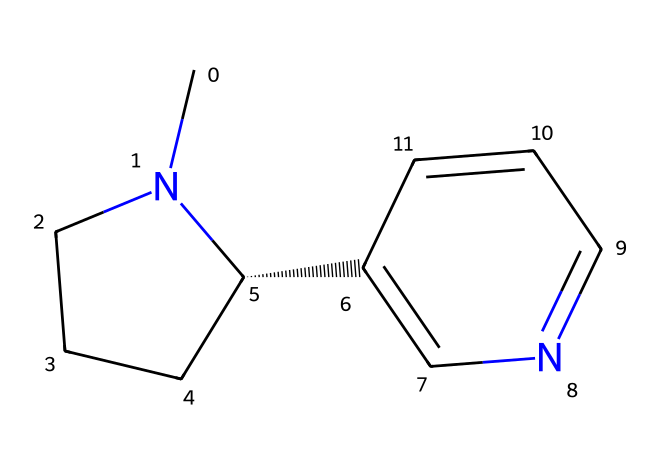How many carbon atoms are in nicotine? By analyzing the SMILES representation, C indicates carbon atoms. Counting all the 'C's gives us a total of ten carbon atoms.
Answer: ten How many nitrogen atoms are present in the structure? The SMILES contains 'N' symbols, which represent nitrogen atoms. By counting these, we find there are two nitrogen atoms in the structure.
Answer: two What type of chemical is nicotine? Nicotine is classified as an alkaloid, which is indicated by the presence of nitrogen in a cyclic structure common to alkaloids.
Answer: alkaloid Is there any aromatic ring in nicotine? The presence of alternating double bonds in the structure indicates that there is an aromatic system, specifically within the part of the structure denoted as "C2=CN=CC=C2".
Answer: yes How many rings are present in the nicotine structure? An examination of the SMILES shows a cyclic structure denoted by the 'C1' and 'C2', indicating the presence of two rings in the overall structure.
Answer: two What functional group is indicative of the imide classification in nicotine? The nitrogen atoms involved in a cyclic structure contributes to its classification as an imide, as imides are characterized by the presence of nitrogen atoms in aromatic or cyclic configurations.
Answer: imide 